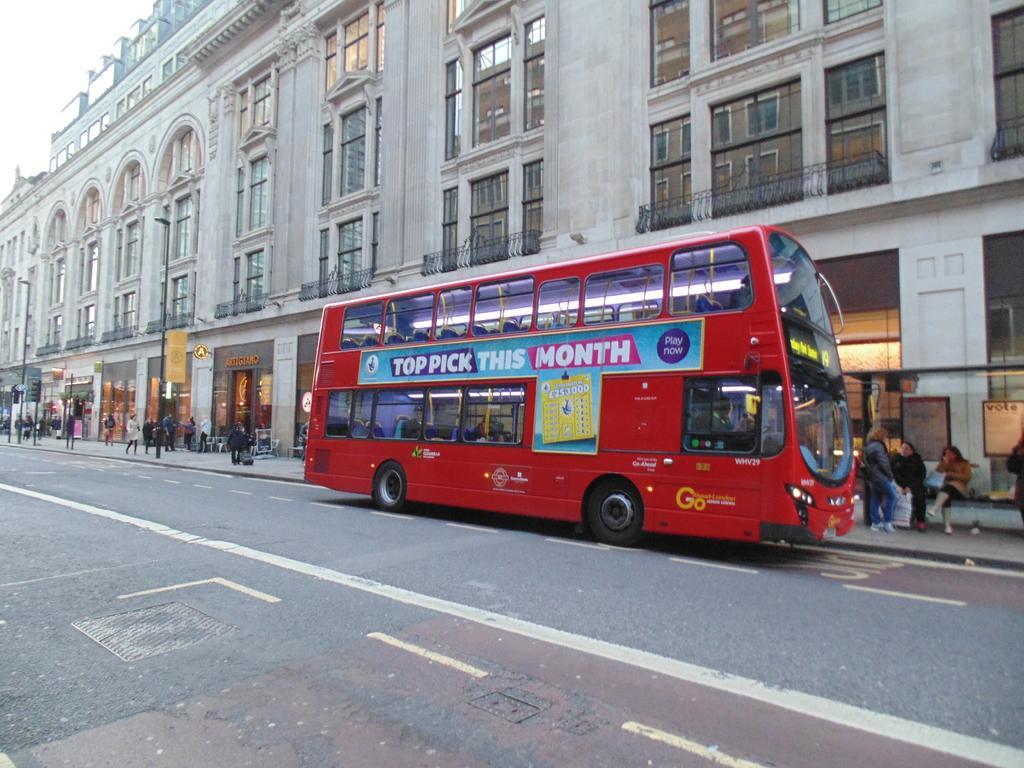Could you give a brief overview of what you see in this image? The picture is taken outside a city. In the foreground of the picture it is road, on the road there is a bus. In the center of the picture there is a footpath, on the footpath there are people walking. In the background there is a building, windows and street lights. 